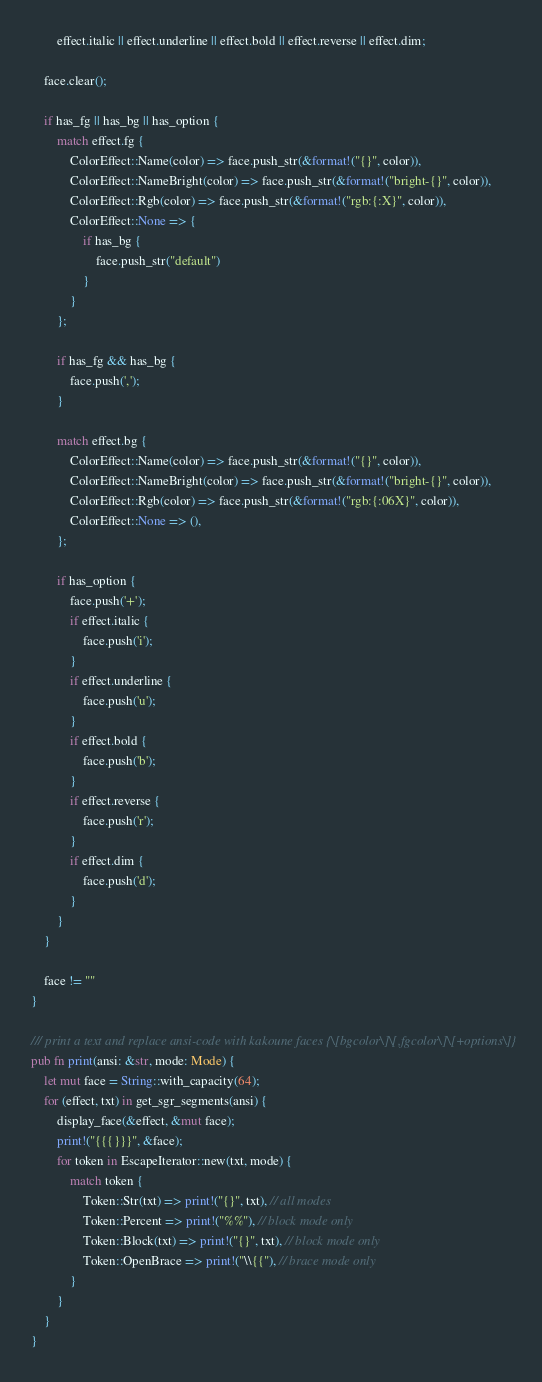<code> <loc_0><loc_0><loc_500><loc_500><_Rust_>		effect.italic || effect.underline || effect.bold || effect.reverse || effect.dim;

	face.clear();

	if has_fg || has_bg || has_option {
		match effect.fg {
			ColorEffect::Name(color) => face.push_str(&format!("{}", color)),
			ColorEffect::NameBright(color) => face.push_str(&format!("bright-{}", color)),
			ColorEffect::Rgb(color) => face.push_str(&format!("rgb:{:X}", color)),
			ColorEffect::None => {
				if has_bg {
					face.push_str("default")
				}
			}
		};

		if has_fg && has_bg {
			face.push(',');
		}

		match effect.bg {
			ColorEffect::Name(color) => face.push_str(&format!("{}", color)),
			ColorEffect::NameBright(color) => face.push_str(&format!("bright-{}", color)),
			ColorEffect::Rgb(color) => face.push_str(&format!("rgb:{:06X}", color)),
			ColorEffect::None => (),
		};

		if has_option {
			face.push('+');
			if effect.italic {
				face.push('i');
			}
			if effect.underline {
				face.push('u');
			}
			if effect.bold {
				face.push('b');
			}
			if effect.reverse {
				face.push('r');
			}
			if effect.dim {
				face.push('d');
			}
		}
	}

	face != ""
}

/// print a text and replace ansi-code with kakoune faces {\[bgcolor\]\[,fgcolor\]\[+options\]}
pub fn print(ansi: &str, mode: Mode) {
	let mut face = String::with_capacity(64);
	for (effect, txt) in get_sgr_segments(ansi) {
		display_face(&effect, &mut face);
		print!("{{{}}}", &face);
		for token in EscapeIterator::new(txt, mode) {
			match token {
				Token::Str(txt) => print!("{}", txt), // all modes
				Token::Percent => print!("%%"), // block mode only
				Token::Block(txt) => print!("{}", txt), // block mode only
				Token::OpenBrace => print!("\\{{"), // brace mode only
			}
		}
	}
}
</code> 